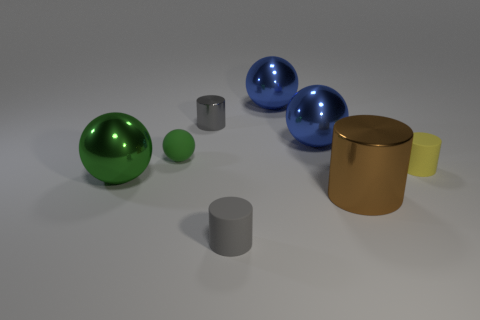What material is the tiny object that is the same color as the small shiny cylinder?
Give a very brief answer. Rubber. What number of other objects are there of the same color as the tiny sphere?
Your response must be concise. 1. How many other things are made of the same material as the small green ball?
Offer a very short reply. 2. Do the small gray cylinder that is to the left of the gray rubber cylinder and the yellow cylinder have the same material?
Provide a succinct answer. No. Is the number of big blue things behind the tiny green sphere greater than the number of big things that are right of the large green metallic ball?
Ensure brevity in your answer.  No. What number of objects are metallic things that are left of the tiny green ball or cyan cubes?
Provide a short and direct response. 1. There is a tiny gray thing that is the same material as the tiny green object; what is its shape?
Give a very brief answer. Cylinder. What color is the tiny rubber object that is both right of the tiny green object and behind the large brown metal cylinder?
Your response must be concise. Yellow. What number of spheres are either tiny rubber objects or big blue things?
Make the answer very short. 3. What number of other objects have the same size as the brown shiny object?
Keep it short and to the point. 3. 